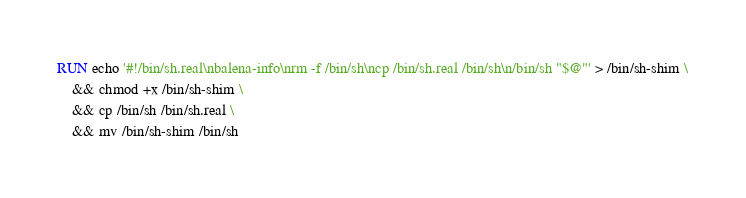Convert code to text. <code><loc_0><loc_0><loc_500><loc_500><_Dockerfile_>
RUN echo '#!/bin/sh.real\nbalena-info\nrm -f /bin/sh\ncp /bin/sh.real /bin/sh\n/bin/sh "$@"' > /bin/sh-shim \
	&& chmod +x /bin/sh-shim \
	&& cp /bin/sh /bin/sh.real \
	&& mv /bin/sh-shim /bin/sh</code> 